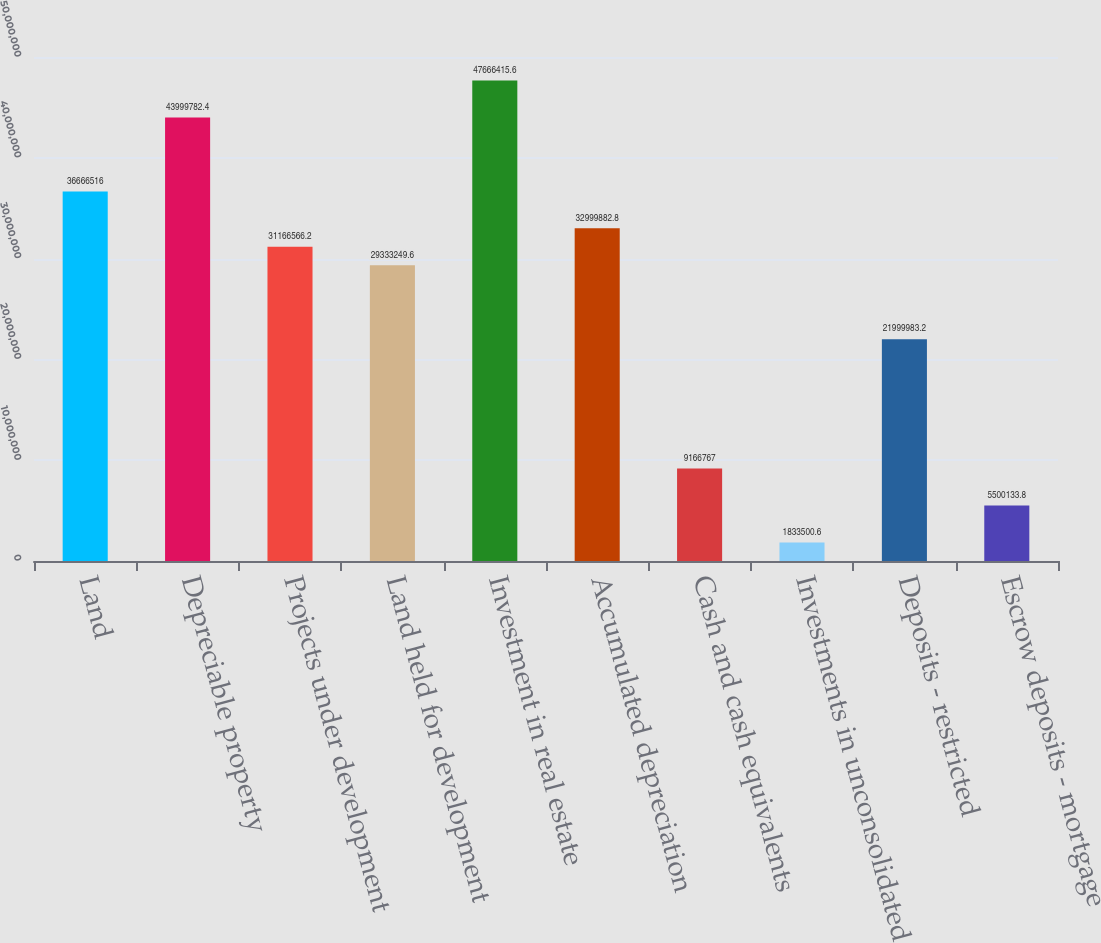Convert chart. <chart><loc_0><loc_0><loc_500><loc_500><bar_chart><fcel>Land<fcel>Depreciable property<fcel>Projects under development<fcel>Land held for development<fcel>Investment in real estate<fcel>Accumulated depreciation<fcel>Cash and cash equivalents<fcel>Investments in unconsolidated<fcel>Deposits - restricted<fcel>Escrow deposits - mortgage<nl><fcel>3.66665e+07<fcel>4.39998e+07<fcel>3.11666e+07<fcel>2.93332e+07<fcel>4.76664e+07<fcel>3.29999e+07<fcel>9.16677e+06<fcel>1.8335e+06<fcel>2.2e+07<fcel>5.50013e+06<nl></chart> 